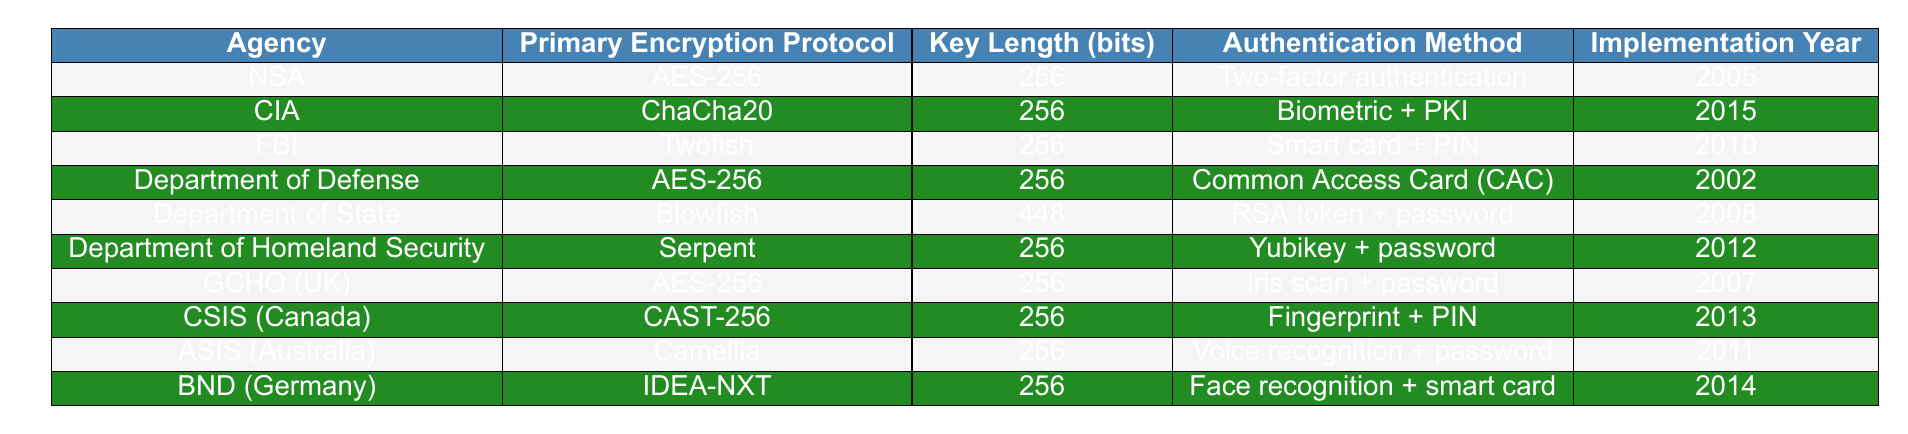What is the primary encryption protocol used by the CIA? The table lists the CIA's primary encryption protocol under the "Primary Encryption Protocol" column which states it is "ChaCha20."
Answer: ChaCha20 Which agency uses the Blowfish encryption protocol? By reviewing the table, it shows that the "Department of State" uses "Blowfish" as their primary encryption protocol.
Answer: Department of State What is the key length used by the FBI for their encryption? The "Key Length (bits)" column indicates that the FBI uses a key length of 256 bits for their "Twofish" encryption.
Answer: 256 Which agencies implemented their encryption protocols in the year 2008 or earlier? Looking at the "Implementation Year" column, the agencies that implemented their protocols in 2008 or earlier are NSA (2005), Department of Defense (2002), and Department of State (2008).
Answer: NSA, Department of Defense, Department of State What is the most common key length used by the agencies listed in the table? By inspecting the "Key Length (bits)" column, 256 bits is the most frequently reported key length among the agencies listed.
Answer: 256 bits Is it true that all agencies listed use a key length of 256 bits? By checking the "Key Length (bits)" column, it is seen that the Department of State uses a key length of 448 bits, meaning not all agencies use 256 bits.
Answer: No How many agencies use AES-256 as their primary encryption protocol? There are three entries under the "Primary Encryption Protocol" that list AES-256, specifically NSA, Department of Defense, and GCHQ (UK). So, adding them gives a total of 3 agencies.
Answer: 3 What is the authentication method used by the Department of Homeland Security? The table shows that the Department of Homeland Security uses "Yubikey + password" as its authentication method.
Answer: Yubikey + password Which encryption protocol has the longest key length in the table? Observing the "Key Length (bits)" column, Blowfish has a key length of 448 bits, which is greater than the 256 bits used by other listed protocols.
Answer: Blowfish Which two agencies have a key length of 256 bits and implemented their encryption around the same time? The agencies using a key length of 256 bits, implemented around the same time are NSA (2005) and GCHQ (UK) (2007). Both are in proximity of 2 years in the implementation year.
Answer: NSA, GCHQ (UK) 